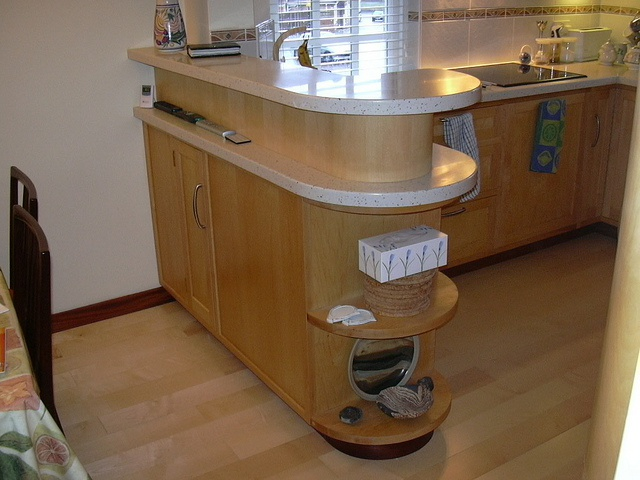Describe the objects in this image and their specific colors. I can see dining table in gray, darkgray, and black tones, chair in gray, black, maroon, and olive tones, sink in gray, maroon, and black tones, vase in gray, black, and maroon tones, and remote in gray and black tones in this image. 